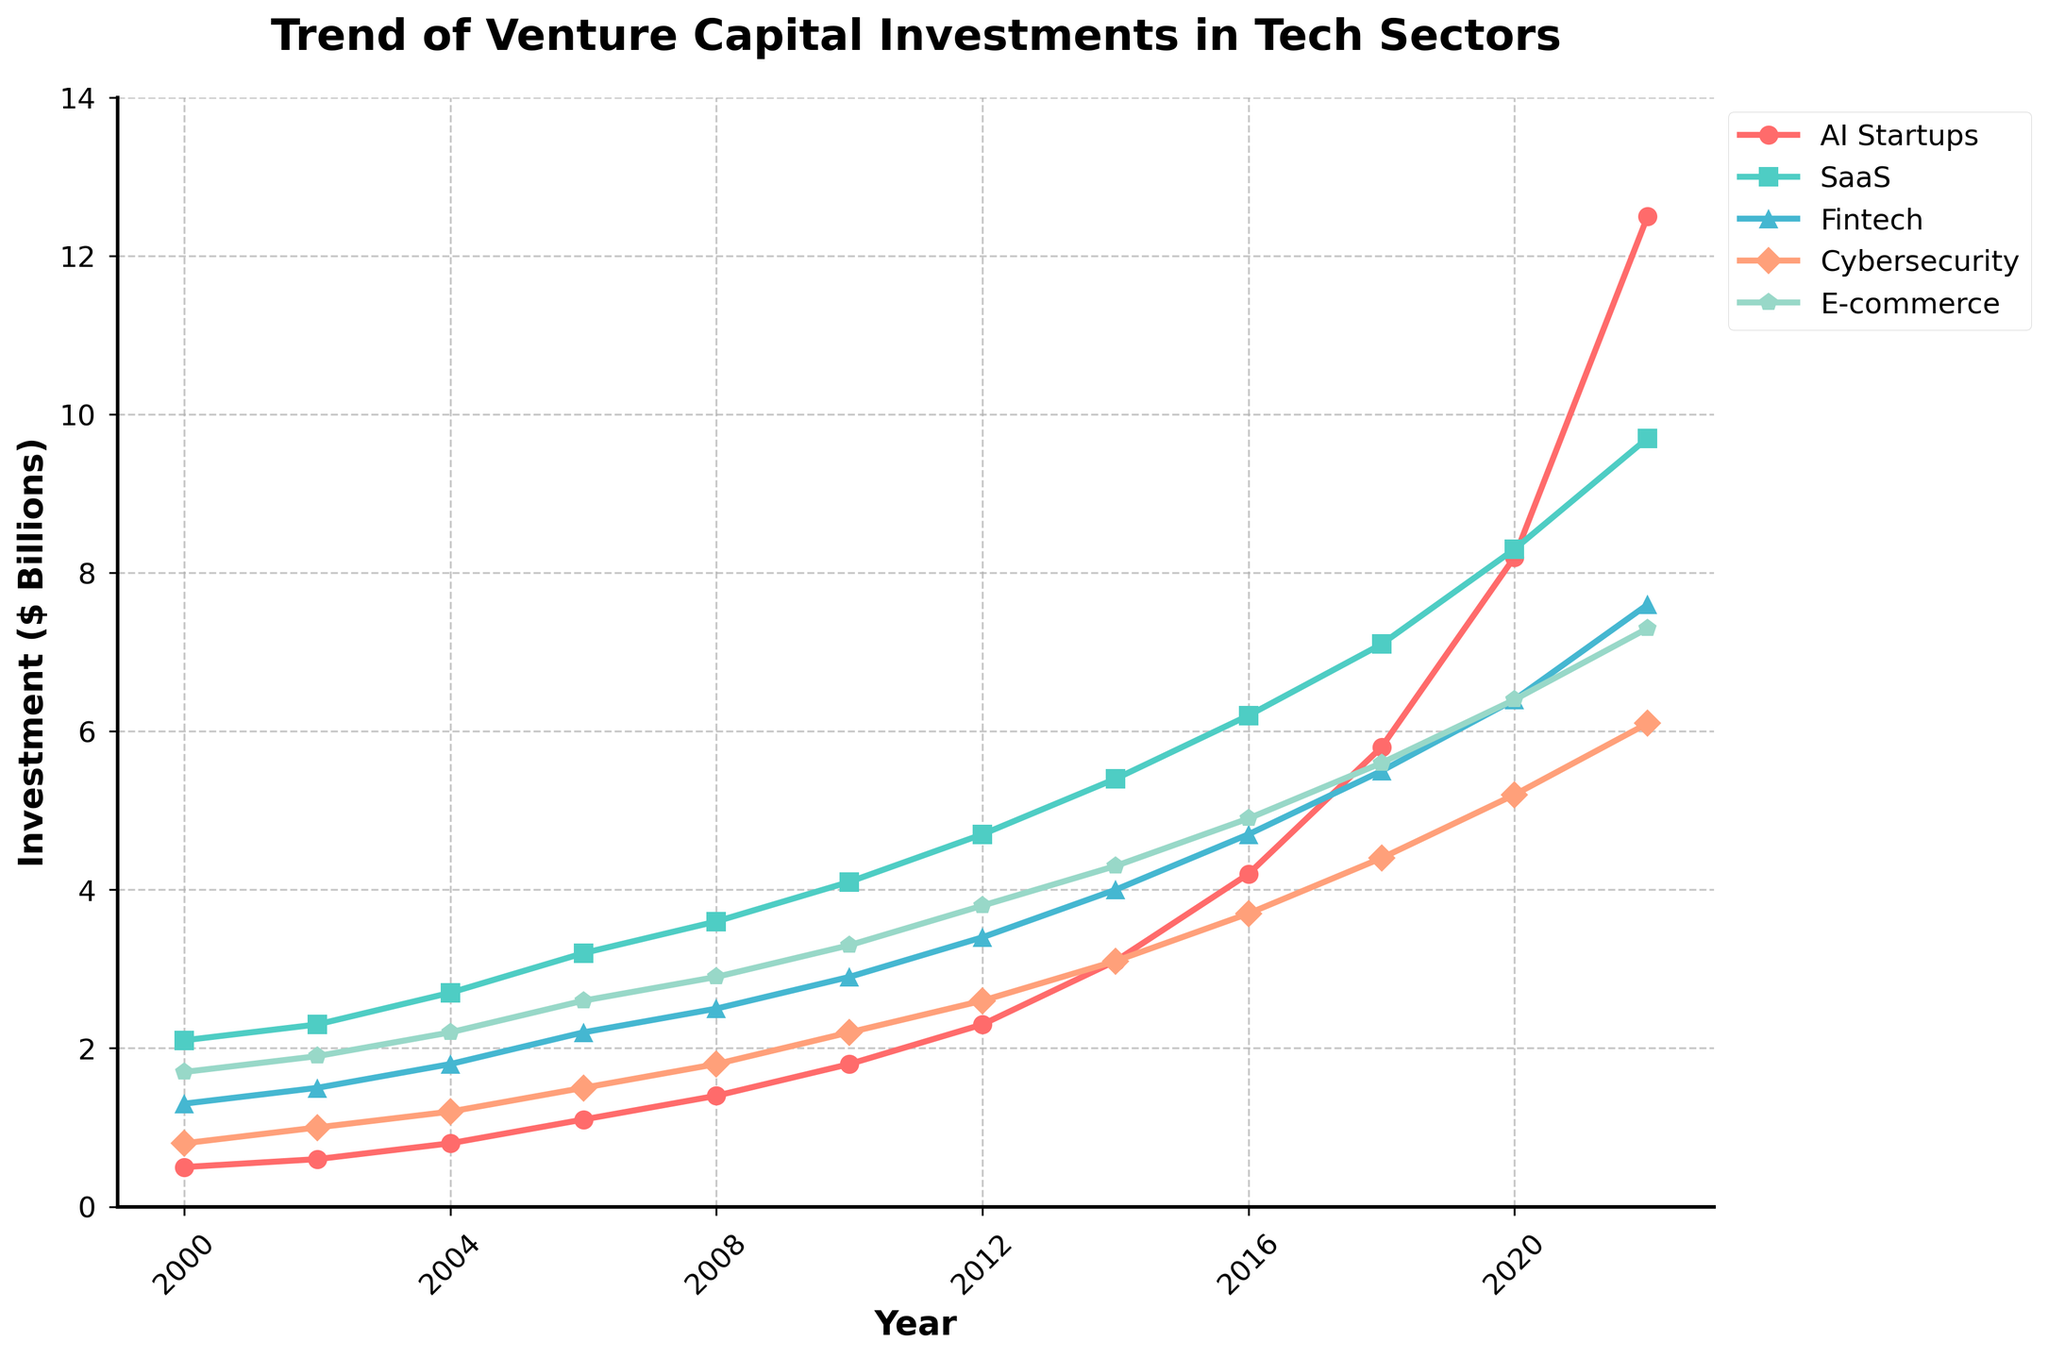What is the investment trend in AI startups between 2000 and 2022? To determine the trend, observe the line corresponding to AI startups from 2000 to 2022. Investments start at 0.5 billion in 2000 and steadily increase to 12.5 billion in 2022. This indicates a sharply rising trend over the years.
Answer: Increasing Which tech sector had the highest venture capital investment in 2022? To find this, compare the data points for all sectors in 2022. The values are 12.5 (AI Startups), 9.7 (SaaS), 7.6 (Fintech), 6.1 (Cybersecurity), and 7.3 (E-commerce). AI Startups have the highest investment in 2022.
Answer: AI Startups How much more was invested in AI startups compared to SaaS companies in 2022? Look at the 2022 data points for AI Startups (12.5 billion) and SaaS (9.7 billion). Subtract the SaaS value from the AI Startups value: 12.5 - 9.7 = 2.8 billion.
Answer: 2.8 billion What is the difference in investment between AI startups and Cybersecurity companies in 2016? Check the investment values for AI Startups (4.2 billion) and Cybersecurity (3.7 billion) in 2016 and subtract the second from the first: 4.2 - 3.7 = 0.5 billion.
Answer: 0.5 billion Which sector showed the most consistent growth from 2000 to 2022? To identify consistent growth, observe the line slopes for each sector across the years. AI Startups plotting shows a consistent upward slope without fluctuation, indicating the most consistent growth pattern.
Answer: AI Startups What is the average investment in AI startups from 2000 to 2022? Sum the investment values for AI Startups over the years: 0.5 + 0.6 + 0.8 + 1.1 + 1.4 + 1.8 + 2.3 + 3.1 + 4.2 + 5.8 + 8.2 + 12.5 = 42.3 billion. There are 12 data points, so divide the sum by 12: 42.3 / 12 ≈ 3.53 billion.
Answer: 3.53 billion Which sector had the smallest investment growth from 2000 to 2022? Compare the starting and ending investment values for all sectors. E-commerce starts at 1.7 billion in 2000 and grows to 7.3 billion in 2022, which is the smallest growth if we consider the investment multiples in other sectors.
Answer: E-commerce In which year did AI startups see the highest year-over-year growth? Observe the differences in consecutive investments for AI Startups across the years. The highest growth is from 8.2 billion in 2020 to 12.5 billion in 2022, a growth of 4.3 billion.
Answer: From 2020 to 2022 What is the total investment in SaaS and Fintech combined for 2020? Add the investment values for SaaS (8.3 billion) and Fintech (6.4 billion) for the year 2020: 8.3 + 6.4 = 14.7 billion.
Answer: 14.7 billion Which sector has the highest peak earlier than 2020, and what is its peak year and value? Compare the peak values for each sector before 2020. For SaaS, the peak before 2020 is 7.1 billion in 2018, which is the highest among all sectors before 2020.
Answer: SaaS, 2018, 7.1 billion 